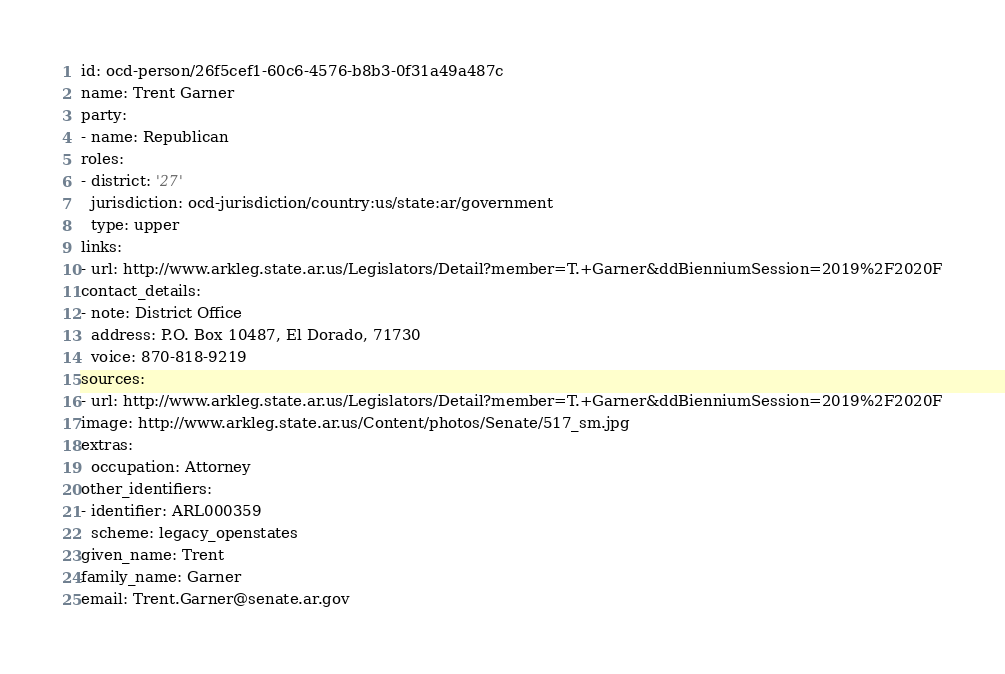<code> <loc_0><loc_0><loc_500><loc_500><_YAML_>id: ocd-person/26f5cef1-60c6-4576-b8b3-0f31a49a487c
name: Trent Garner
party:
- name: Republican
roles:
- district: '27'
  jurisdiction: ocd-jurisdiction/country:us/state:ar/government
  type: upper
links:
- url: http://www.arkleg.state.ar.us/Legislators/Detail?member=T.+Garner&ddBienniumSession=2019%2F2020F
contact_details:
- note: District Office
  address: P.O. Box 10487, El Dorado, 71730
  voice: 870-818-9219
sources:
- url: http://www.arkleg.state.ar.us/Legislators/Detail?member=T.+Garner&ddBienniumSession=2019%2F2020F
image: http://www.arkleg.state.ar.us/Content/photos/Senate/517_sm.jpg
extras:
  occupation: Attorney
other_identifiers:
- identifier: ARL000359
  scheme: legacy_openstates
given_name: Trent
family_name: Garner
email: Trent.Garner@senate.ar.gov
</code> 